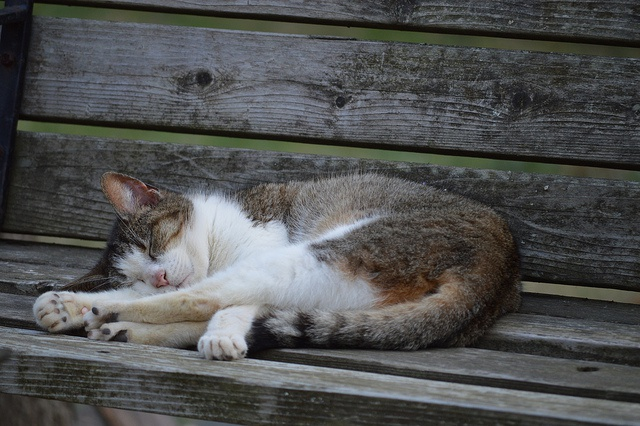Describe the objects in this image and their specific colors. I can see bench in black and gray tones and cat in black, gray, darkgray, and lightgray tones in this image. 